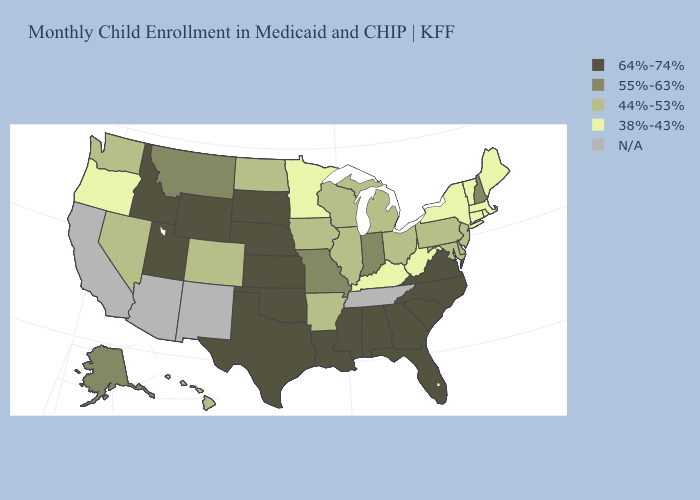What is the highest value in states that border Oregon?
Write a very short answer. 64%-74%. Among the states that border Virginia , does North Carolina have the highest value?
Give a very brief answer. Yes. Name the states that have a value in the range 55%-63%?
Answer briefly. Alaska, Indiana, Missouri, Montana, New Hampshire. What is the value of New Jersey?
Quick response, please. 44%-53%. What is the lowest value in the MidWest?
Keep it brief. 38%-43%. What is the lowest value in the West?
Short answer required. 38%-43%. What is the value of Pennsylvania?
Answer briefly. 44%-53%. Which states have the highest value in the USA?
Keep it brief. Alabama, Florida, Georgia, Idaho, Kansas, Louisiana, Mississippi, Nebraska, North Carolina, Oklahoma, South Carolina, South Dakota, Texas, Utah, Virginia, Wyoming. Does the map have missing data?
Short answer required. Yes. What is the value of Delaware?
Answer briefly. 44%-53%. Does Minnesota have the lowest value in the USA?
Give a very brief answer. Yes. What is the value of Minnesota?
Write a very short answer. 38%-43%. What is the value of Missouri?
Concise answer only. 55%-63%. Among the states that border Florida , which have the lowest value?
Keep it brief. Alabama, Georgia. 